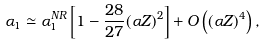Convert formula to latex. <formula><loc_0><loc_0><loc_500><loc_500>\alpha _ { 1 } \simeq \alpha _ { 1 } ^ { N R } \left [ 1 - \frac { 2 8 } { 2 7 } ( \alpha Z ) ^ { 2 } \right ] + O \left ( ( \alpha Z ) ^ { 4 } \right ) ,</formula> 